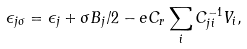<formula> <loc_0><loc_0><loc_500><loc_500>\epsilon _ { j \sigma } = \epsilon _ { j } + \sigma B _ { j } / 2 - e C _ { r } \sum _ { i } C _ { j i } ^ { - 1 } V _ { i } ,</formula> 